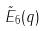Convert formula to latex. <formula><loc_0><loc_0><loc_500><loc_500>\tilde { E } _ { 6 } ( q )</formula> 